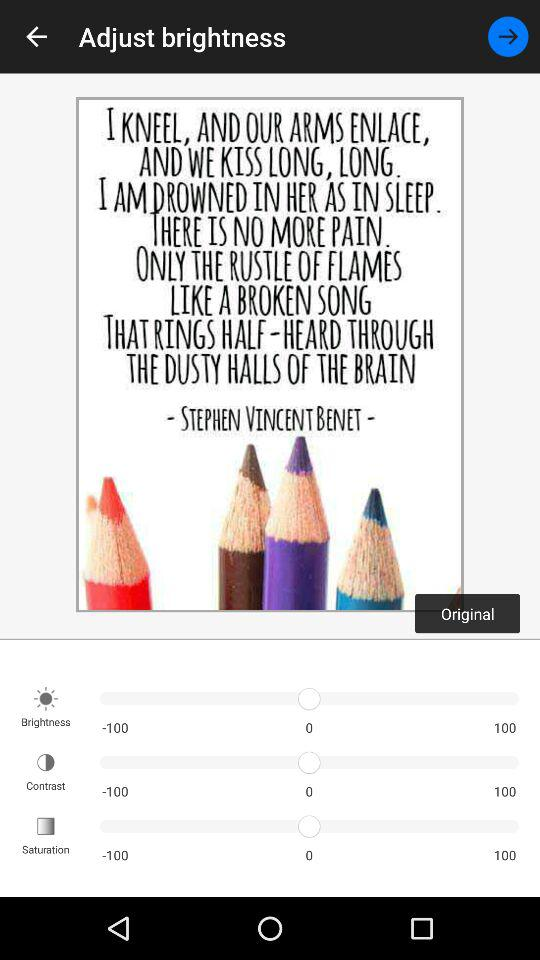What frequency should I use to change the brightness?
When the provided information is insufficient, respond with <no answer>. <no answer> 